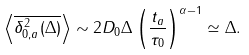<formula> <loc_0><loc_0><loc_500><loc_500>\left \langle \overline { \delta _ { 0 , a } ^ { 2 } ( \Delta ) } \right \rangle \sim 2 D _ { 0 } \Delta \left ( \frac { t _ { a } } { \tau _ { 0 } } \right ) ^ { \alpha - 1 } \simeq \Delta .</formula> 